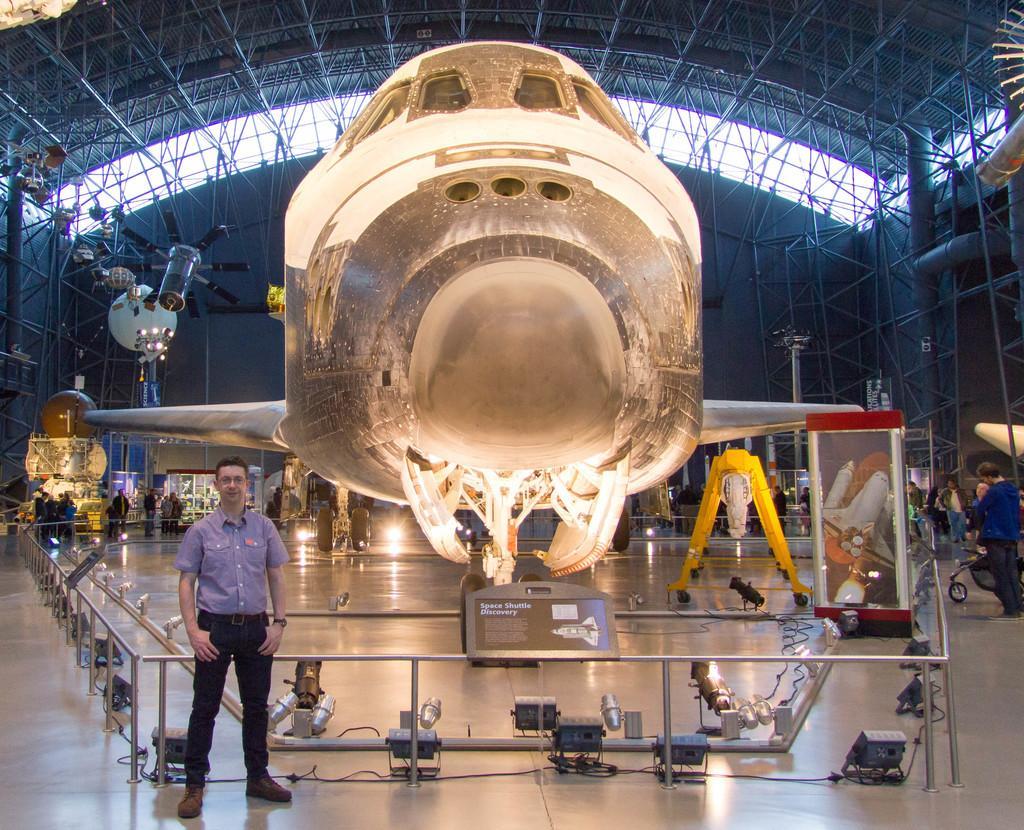Please provide a concise description of this image. In this image I can see a person wearing shirt and black color pant is standing. I can see the metal railing, few lights, a banner and an aircraft which is gold in color on the ground. In the background I can see few persons standing on the ground, the ceiling, number of metal rods, few lights, few objects hanging in the air and the sky through the ceiling. 